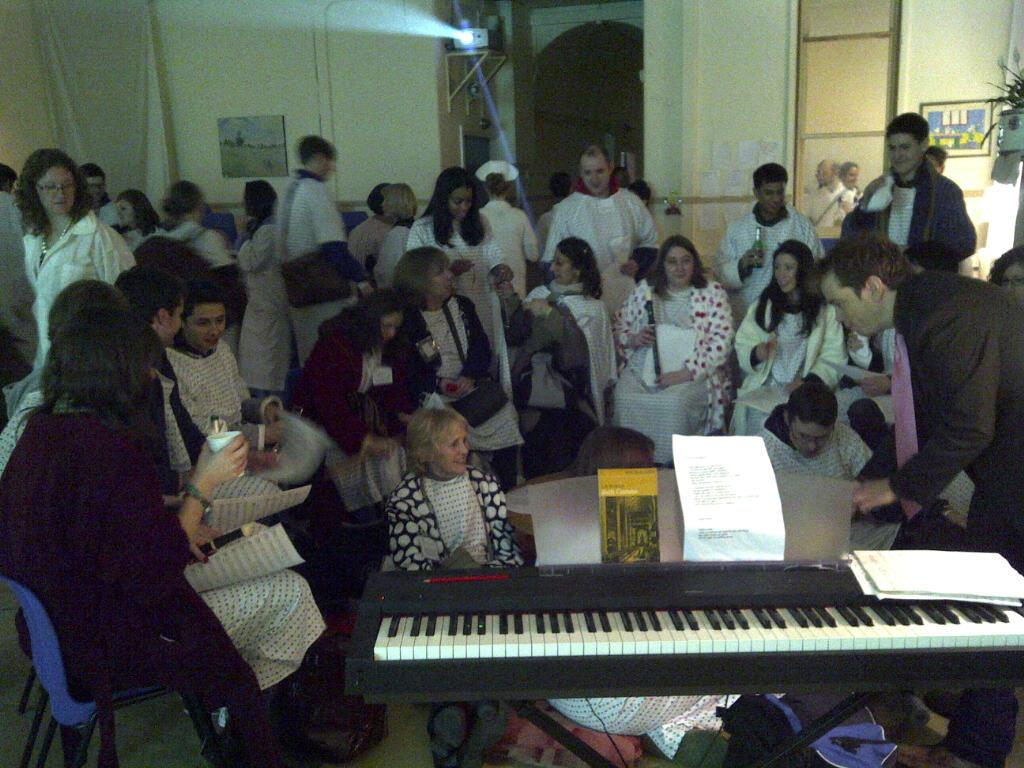What are the majority of persons in the image doing? Most of the persons are standing. What are the others doing? Few persons are sitting. What musical instrument is visible in the image? There is a piano keyboard in the image. What is placed on the piano keyboard? Papers are on the piano keyboard. What can be seen on the wall in the image? There is a picture on the wall. What device is present in the image for displaying visuals? There is a projector in the image. What type of badge can be seen on the persons in the image? There is no badge visible on the persons in the image. What kind of clouds can be seen through the window in the image? There is no window or clouds present in the image. 